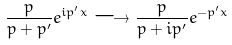Convert formula to latex. <formula><loc_0><loc_0><loc_500><loc_500>\frac { p } { p + p ^ { \prime } } e ^ { i p ^ { \prime } x } \longrightarrow \frac { p } { p + i p ^ { \prime } } e ^ { - p ^ { \prime } x }</formula> 